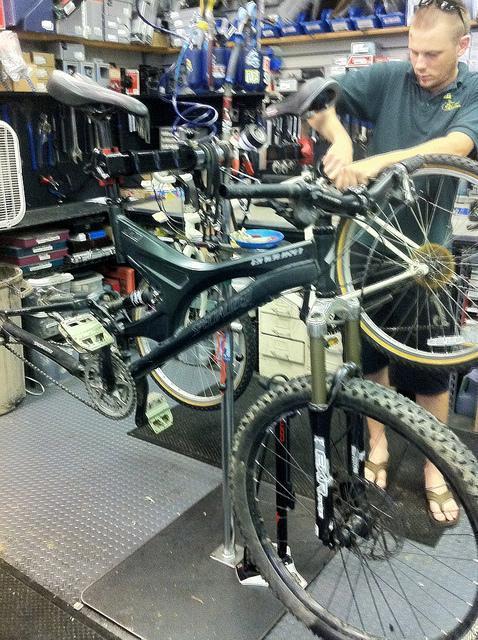How many bicycles are there?
Give a very brief answer. 2. How many boats are there?
Give a very brief answer. 0. 